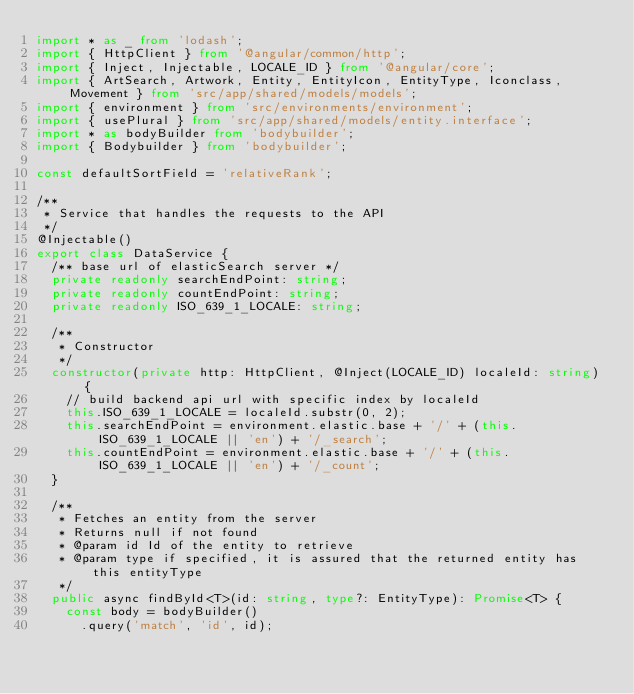Convert code to text. <code><loc_0><loc_0><loc_500><loc_500><_TypeScript_>import * as _ from 'lodash';
import { HttpClient } from '@angular/common/http';
import { Inject, Injectable, LOCALE_ID } from '@angular/core';
import { ArtSearch, Artwork, Entity, EntityIcon, EntityType, Iconclass, Movement } from 'src/app/shared/models/models';
import { environment } from 'src/environments/environment';
import { usePlural } from 'src/app/shared/models/entity.interface';
import * as bodyBuilder from 'bodybuilder';
import { Bodybuilder } from 'bodybuilder';

const defaultSortField = 'relativeRank';

/**
 * Service that handles the requests to the API
 */
@Injectable()
export class DataService {
  /** base url of elasticSearch server */
  private readonly searchEndPoint: string;
  private readonly countEndPoint: string;
  private readonly ISO_639_1_LOCALE: string;

  /**
   * Constructor
   */
  constructor(private http: HttpClient, @Inject(LOCALE_ID) localeId: string) {
    // build backend api url with specific index by localeId
    this.ISO_639_1_LOCALE = localeId.substr(0, 2);
    this.searchEndPoint = environment.elastic.base + '/' + (this.ISO_639_1_LOCALE || 'en') + '/_search';
    this.countEndPoint = environment.elastic.base + '/' + (this.ISO_639_1_LOCALE || 'en') + '/_count';
  }

  /**
   * Fetches an entity from the server
   * Returns null if not found
   * @param id Id of the entity to retrieve
   * @param type if specified, it is assured that the returned entity has this entityType
   */
  public async findById<T>(id: string, type?: EntityType): Promise<T> {
    const body = bodyBuilder()
      .query('match', 'id', id);</code> 